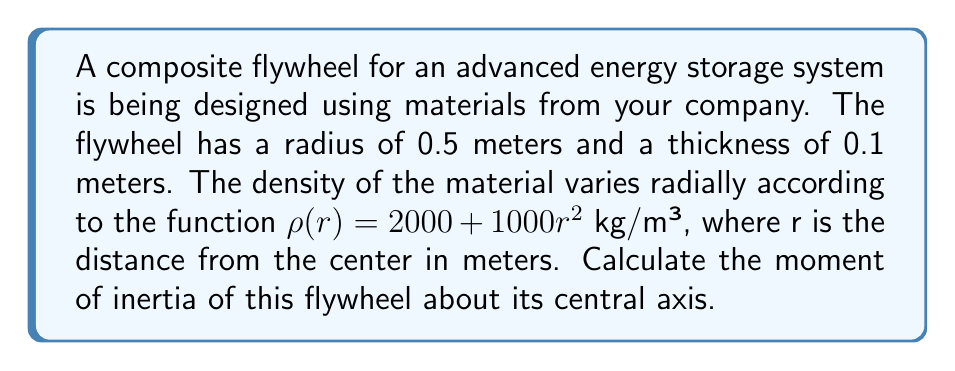Can you solve this math problem? To solve this problem, we'll use the formula for the moment of inertia of a disk with varying density in polar coordinates:

$$I = \int_0^{2\pi} \int_0^R \rho(r) r^3 dr d\theta$$

Where:
- $R$ is the radius of the flywheel (0.5 m)
- $\rho(r)$ is the density function $(2000 + 1000r^2)$ kg/m³
- $r$ is the distance from the center

Steps:

1) First, we set up the integral:

   $$I = \int_0^{2\pi} \int_0^{0.5} (2000 + 1000r^2) r^3 dr d\theta$$

2) The inner integral doesn't depend on $\theta$, so we can separate the integrals:

   $$I = 2\pi \int_0^{0.5} (2000r^3 + 1000r^5) dr$$

3) Integrate with respect to r:

   $$I = 2\pi \left[\frac{2000r^4}{4} + \frac{1000r^6}{6}\right]_0^{0.5}$$

4) Evaluate the integral:

   $$I = 2\pi \left[\frac{2000(0.5)^4}{4} + \frac{1000(0.5)^6}{6} - 0\right]$$

5) Calculate the result:

   $$I = 2\pi \left[\frac{2000(0.0625)}{4} + \frac{1000(0.015625)}{6}\right]$$
   $$I = 2\pi [31.25 + 2.604167]$$
   $$I = 2\pi (33.854167)$$
   $$I = 212.77 \text{ kg·m²}$$

6) Since the flywheel has a thickness of 0.1 m, we multiply the result by 0.1:

   $$I_{\text{total}} = 212.77 \times 0.1 = 21.277 \text{ kg·m²}$$
Answer: The moment of inertia of the composite flywheel is approximately 21.28 kg·m². 